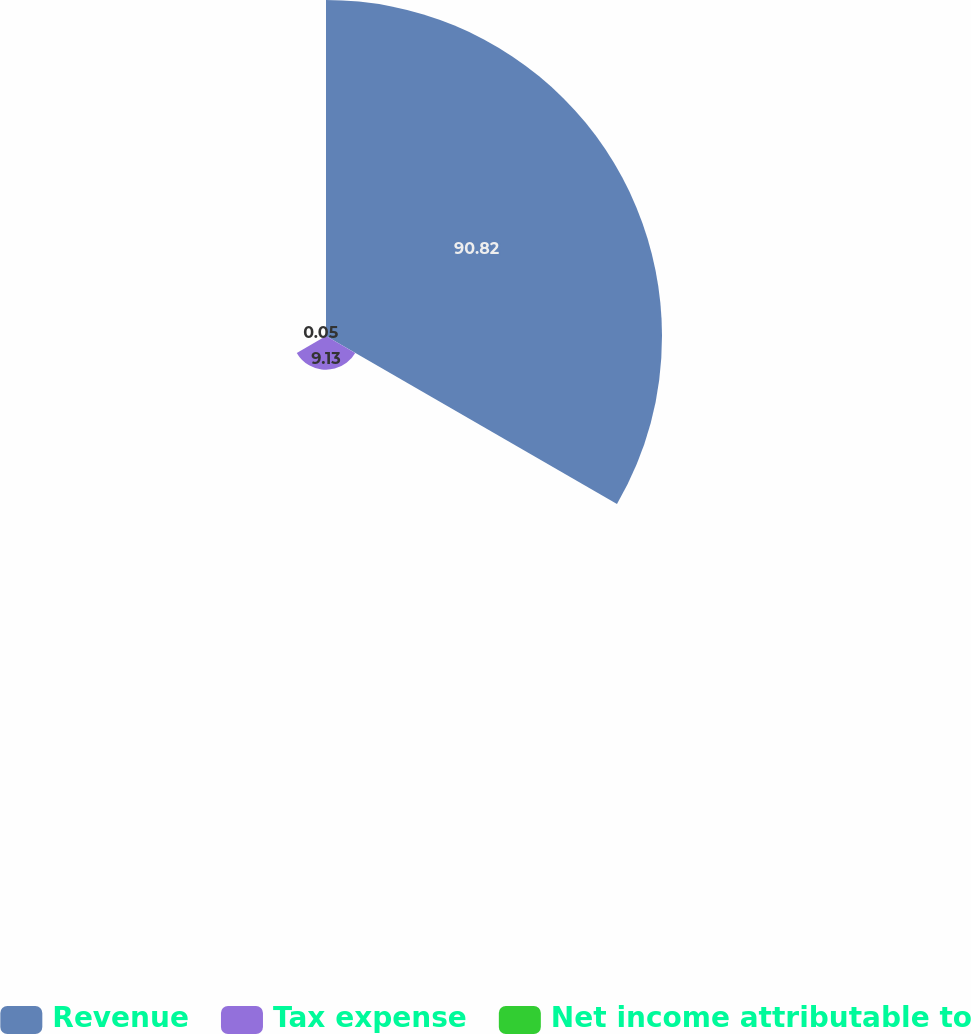Convert chart. <chart><loc_0><loc_0><loc_500><loc_500><pie_chart><fcel>Revenue<fcel>Tax expense<fcel>Net income attributable to<nl><fcel>90.83%<fcel>9.13%<fcel>0.05%<nl></chart> 